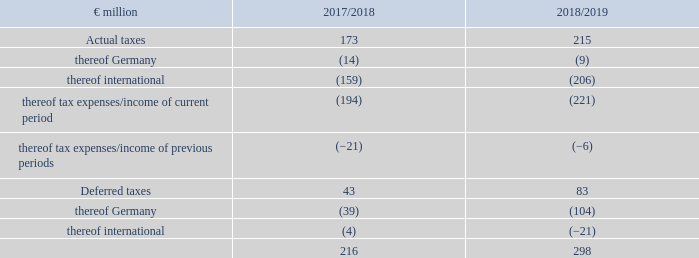12. Income taxes
Income taxes include the taxes on income paid or owed in the individual countries as well as deferred taxes.
1 Adjustment of previous year according to explanation in notes.
The income tax rate of the German companies of METRO consists of a corporate income tax of 15.00% plus a 5.50% solidarity surcharge on corporate income tax as well as the trade tax of 14.70% given an average assessment rate of 420.00%. All in all, this results in an aggregate tax rate of 30.53%. The tax rates are unchanged from the previous year. The income tax rates applied to foreign companies are based on the respective laws and regulations of the individual countries and vary within a range of 0.00% (2017/18: 0.00%) and 34.94% (2017/18: 44.41%).
At €298 million (2017/18: €216 million), recognised income tax expenses are €81 million higher than in the previous year. In addition to an increase in pre-tax earnings, the change is due to higher expenses for impairments on deferred taxes, among other things.
What do income taxes include? The taxes on income paid or owed in the individual countries as well as deferred taxes. What are the recognised income tax expenses in 2019? €298 million. What are the components under deferred taxes? Thereof germany, thereof international. In which year were the recognised income tax expenses larger? 298>216
Answer: 2018/2019. What was the change in recognised income tax expenses in 2018/2019 from 2017/2018?
Answer scale should be: million. 298-216
Answer: 82. What was the percentage change in recognised income tax expenses in 2018/2019 from 2017/2018?
Answer scale should be: percent. (298-216)/216
Answer: 37.96. 